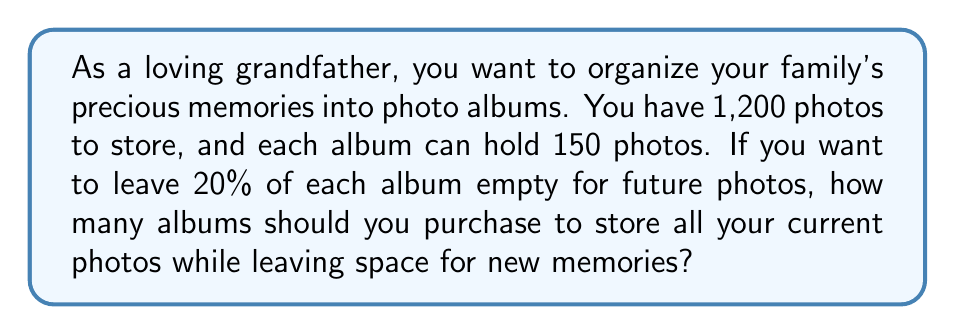Teach me how to tackle this problem. Let's approach this step-by-step:

1. First, we need to calculate the actual capacity of each album when leaving 20% empty:
   $$ \text{Actual capacity} = 150 \times (1 - 0.20) = 150 \times 0.80 = 120 \text{ photos per album} $$

2. Now, we can set up a proportion to find the number of albums needed:
   $$ \frac{120 \text{ photos}}{1 \text{ album}} = \frac{1,200 \text{ photos}}{x \text{ albums}} $$

3. Cross-multiply to solve for $x$:
   $$ 120x = 1,200 $$

4. Divide both sides by 120:
   $$ x = \frac{1,200}{120} = 10 \text{ albums} $$

5. Since we can't buy a fraction of an album, we need to round up to the nearest whole number to ensure we have enough space for all photos.
Answer: You should purchase 10 photo albums to store all 1,200 current photos while leaving 20% space in each album for future memories. 